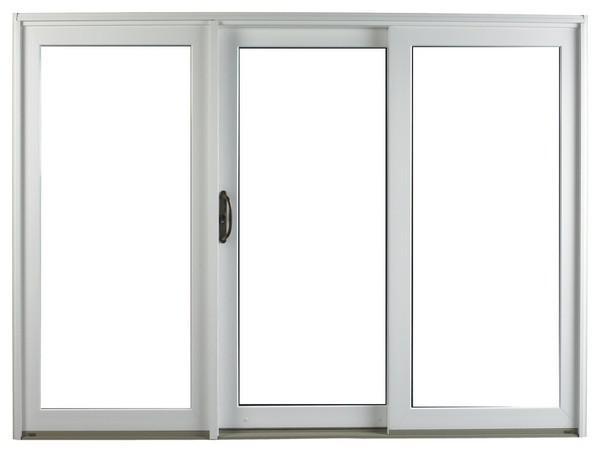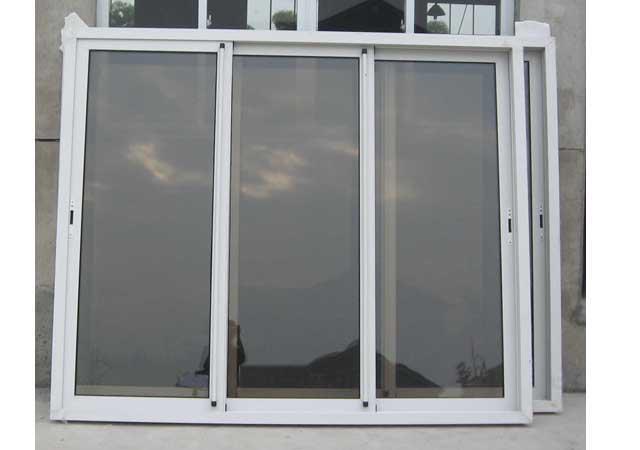The first image is the image on the left, the second image is the image on the right. Examine the images to the left and right. Is the description "In the image to the right, the window's handle is black, and large enough for a solid grip." accurate? Answer yes or no. No. 